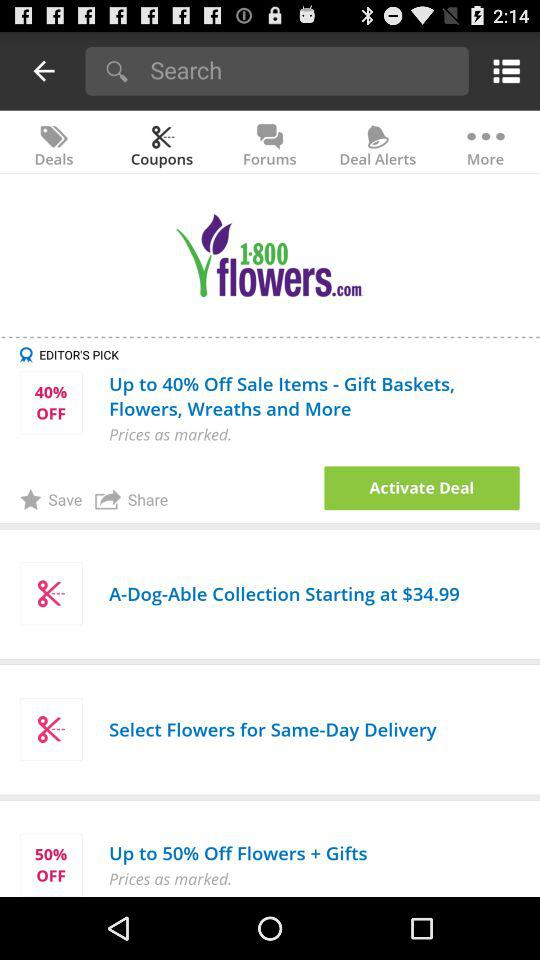Which option is selected? The selected option is "Coupons". 